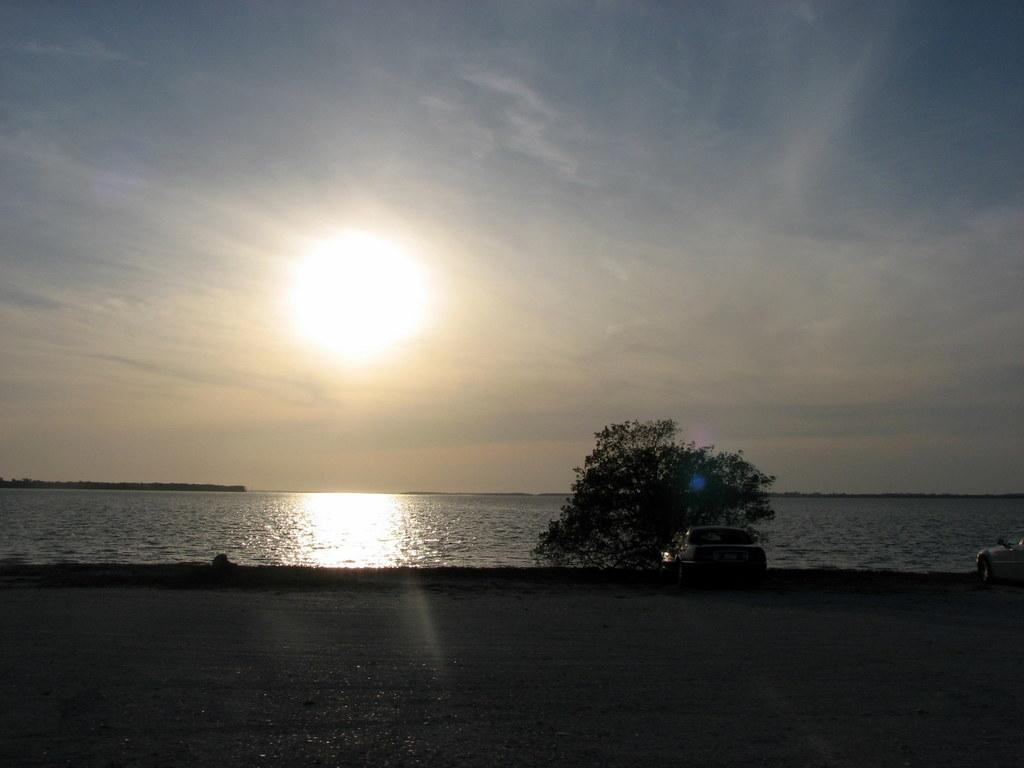What vehicles are located on the right side of the image? There are two cars on the right side of the image. What type of plant can be seen in the image? There is a green color plant in the image. What natural feature is present in the image? There is a sea in the image. What is the substance that covers most of the image? Water is visible in the image. What is visible at the top of the image? The sky is visible at the top of the image. How many necks can be seen on the horses in the image? There are no horses present in the image. What type of fuel is used by the coal-powered vehicles in the image? There are no coal-powered vehicles present in the image. 